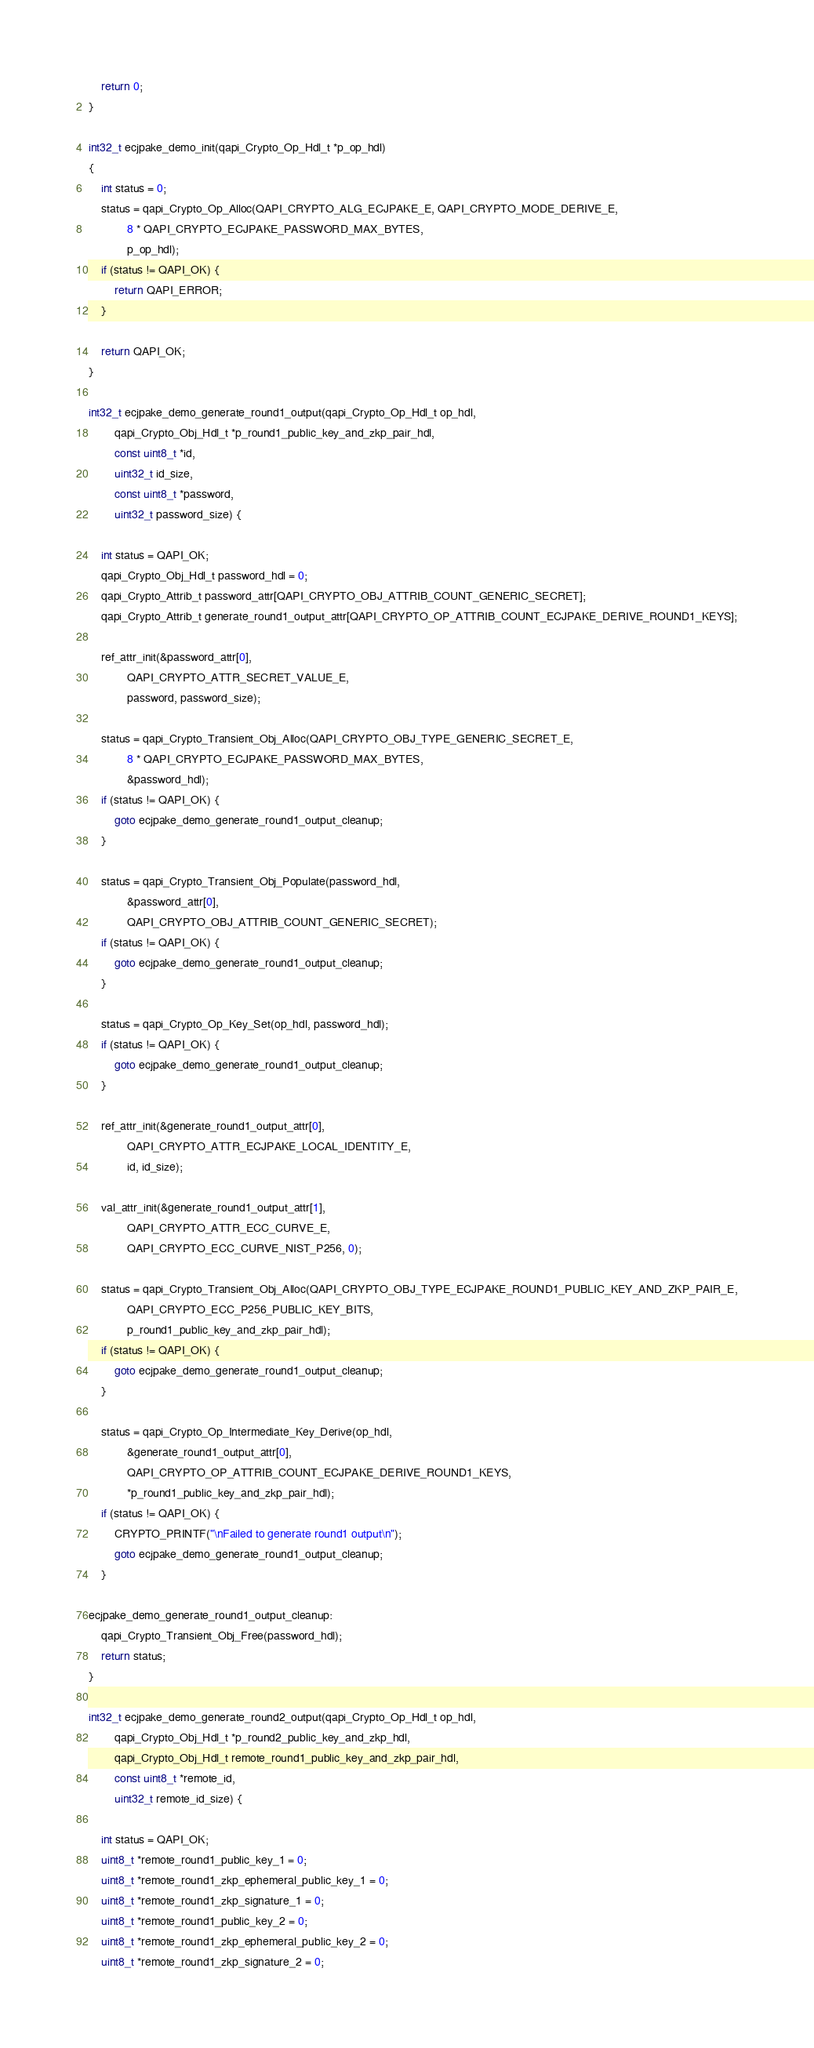Convert code to text. <code><loc_0><loc_0><loc_500><loc_500><_C_>    return 0;
}

int32_t ecjpake_demo_init(qapi_Crypto_Op_Hdl_t *p_op_hdl)
{
	int status = 0;
    status = qapi_Crypto_Op_Alloc(QAPI_CRYPTO_ALG_ECJPAKE_E, QAPI_CRYPTO_MODE_DERIVE_E,
    		8 * QAPI_CRYPTO_ECJPAKE_PASSWORD_MAX_BYTES,
			p_op_hdl);
    if (status != QAPI_OK) {
        return QAPI_ERROR;
    }

    return QAPI_OK;
}

int32_t ecjpake_demo_generate_round1_output(qapi_Crypto_Op_Hdl_t op_hdl,
		qapi_Crypto_Obj_Hdl_t *p_round1_public_key_and_zkp_pair_hdl,
		const uint8_t *id,
		uint32_t id_size,
		const uint8_t *password,
		uint32_t password_size) {

	int status = QAPI_OK;
	qapi_Crypto_Obj_Hdl_t password_hdl = 0;
	qapi_Crypto_Attrib_t password_attr[QAPI_CRYPTO_OBJ_ATTRIB_COUNT_GENERIC_SECRET];
	qapi_Crypto_Attrib_t generate_round1_output_attr[QAPI_CRYPTO_OP_ATTRIB_COUNT_ECJPAKE_DERIVE_ROUND1_KEYS];

	ref_attr_init(&password_attr[0],
			QAPI_CRYPTO_ATTR_SECRET_VALUE_E,
			password, password_size);

	status = qapi_Crypto_Transient_Obj_Alloc(QAPI_CRYPTO_OBJ_TYPE_GENERIC_SECRET_E,
			8 * QAPI_CRYPTO_ECJPAKE_PASSWORD_MAX_BYTES,
			&password_hdl);
    if (status != QAPI_OK) {
    	goto ecjpake_demo_generate_round1_output_cleanup;
    }

	status = qapi_Crypto_Transient_Obj_Populate(password_hdl,
			&password_attr[0],
			QAPI_CRYPTO_OBJ_ATTRIB_COUNT_GENERIC_SECRET);
    if (status != QAPI_OK) {
    	goto ecjpake_demo_generate_round1_output_cleanup;
    }

    status = qapi_Crypto_Op_Key_Set(op_hdl, password_hdl);
    if (status != QAPI_OK) {
    	goto ecjpake_demo_generate_round1_output_cleanup;
    }

	ref_attr_init(&generate_round1_output_attr[0],
			QAPI_CRYPTO_ATTR_ECJPAKE_LOCAL_IDENTITY_E,
			id, id_size);

    val_attr_init(&generate_round1_output_attr[1],
    		QAPI_CRYPTO_ATTR_ECC_CURVE_E,
			QAPI_CRYPTO_ECC_CURVE_NIST_P256, 0);

	status = qapi_Crypto_Transient_Obj_Alloc(QAPI_CRYPTO_OBJ_TYPE_ECJPAKE_ROUND1_PUBLIC_KEY_AND_ZKP_PAIR_E,
    		QAPI_CRYPTO_ECC_P256_PUBLIC_KEY_BITS,
			p_round1_public_key_and_zkp_pair_hdl);
    if (status != QAPI_OK) {
    	goto ecjpake_demo_generate_round1_output_cleanup;
    }

    status = qapi_Crypto_Op_Intermediate_Key_Derive(op_hdl,
    		&generate_round1_output_attr[0],
			QAPI_CRYPTO_OP_ATTRIB_COUNT_ECJPAKE_DERIVE_ROUND1_KEYS,
        	*p_round1_public_key_and_zkp_pair_hdl);
    if (status != QAPI_OK) {
        CRYPTO_PRINTF("\nFailed to generate round1 output\n");
        goto ecjpake_demo_generate_round1_output_cleanup;
    }

ecjpake_demo_generate_round1_output_cleanup:
	qapi_Crypto_Transient_Obj_Free(password_hdl);
    return status;
}

int32_t ecjpake_demo_generate_round2_output(qapi_Crypto_Op_Hdl_t op_hdl,
		qapi_Crypto_Obj_Hdl_t *p_round2_public_key_and_zkp_hdl,
		qapi_Crypto_Obj_Hdl_t remote_round1_public_key_and_zkp_pair_hdl,
		const uint8_t *remote_id,
		uint32_t remote_id_size) {

	int status = QAPI_OK;
    uint8_t *remote_round1_public_key_1 = 0;
    uint8_t *remote_round1_zkp_ephemeral_public_key_1 = 0;
    uint8_t *remote_round1_zkp_signature_1 = 0;
    uint8_t *remote_round1_public_key_2 = 0;
    uint8_t *remote_round1_zkp_ephemeral_public_key_2 = 0;
    uint8_t *remote_round1_zkp_signature_2 = 0;</code> 